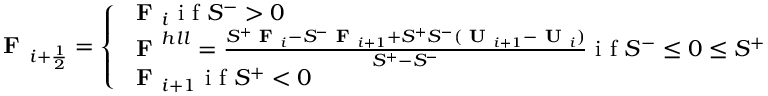<formula> <loc_0><loc_0><loc_500><loc_500>F _ { i + \frac { 1 } { 2 } } = \left \{ \begin{array} { l l } { F _ { i } i f S ^ { - } > 0 } \\ { F ^ { h l l } = \frac { S ^ { + } F _ { i } - S ^ { - } F _ { i + 1 } + S ^ { + } S ^ { - } ( U _ { i + 1 } - U _ { i } ) } { S ^ { + } - S ^ { - } } i f S ^ { - } \leq 0 \leq S ^ { + } } \\ { F _ { i + 1 } i f S ^ { + } < 0 } \end{array}</formula> 